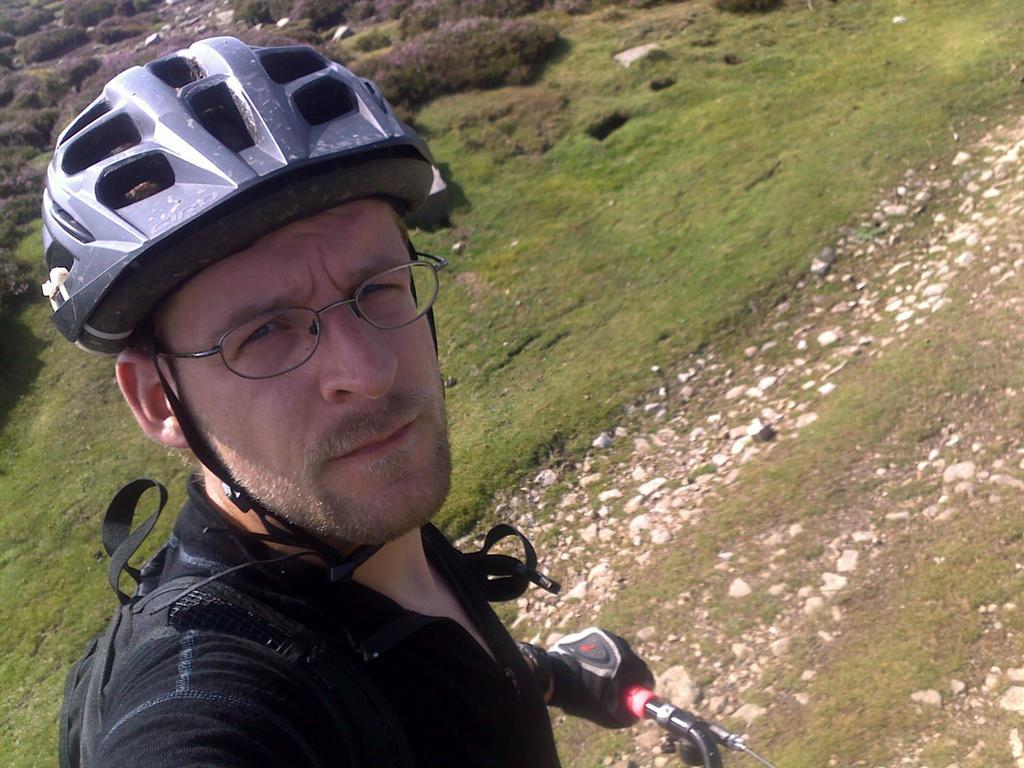What is the main subject of the image? There is a man standing in the image. What is the man holding in his hand? The man is holding a handle in his hand. What can be seen in the background of the image? There is a grassland and plants in the background of the image. What type of bed can be seen in the image? There is no bed present in the image. 